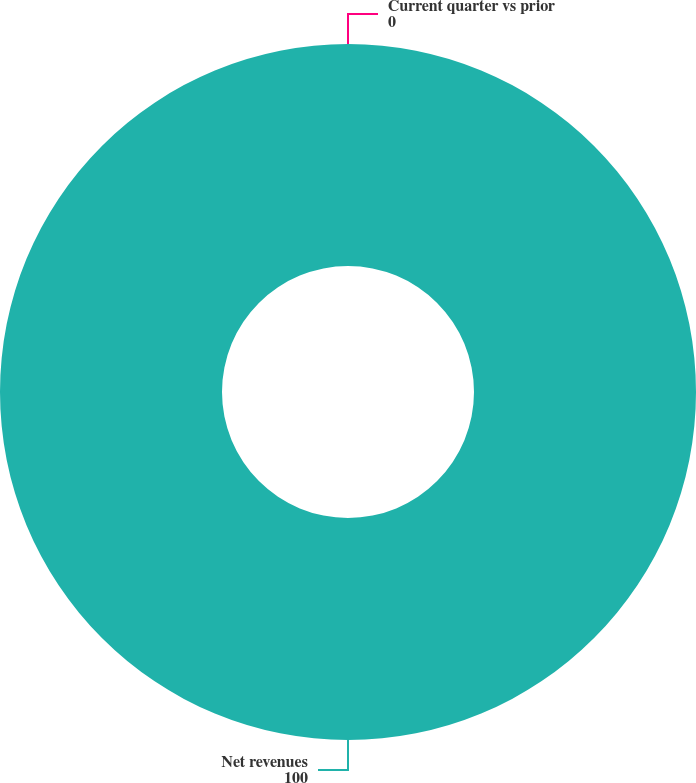Convert chart. <chart><loc_0><loc_0><loc_500><loc_500><pie_chart><fcel>Net revenues<fcel>Current quarter vs prior<nl><fcel>100.0%<fcel>0.0%<nl></chart> 